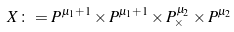<formula> <loc_0><loc_0><loc_500><loc_500>X \colon = P ^ { \mu _ { 1 } + 1 } \times P ^ { \mu _ { 1 } + 1 } \times P ^ { \mu _ { 2 } } _ { \times } \times P ^ { \mu _ { 2 } }</formula> 